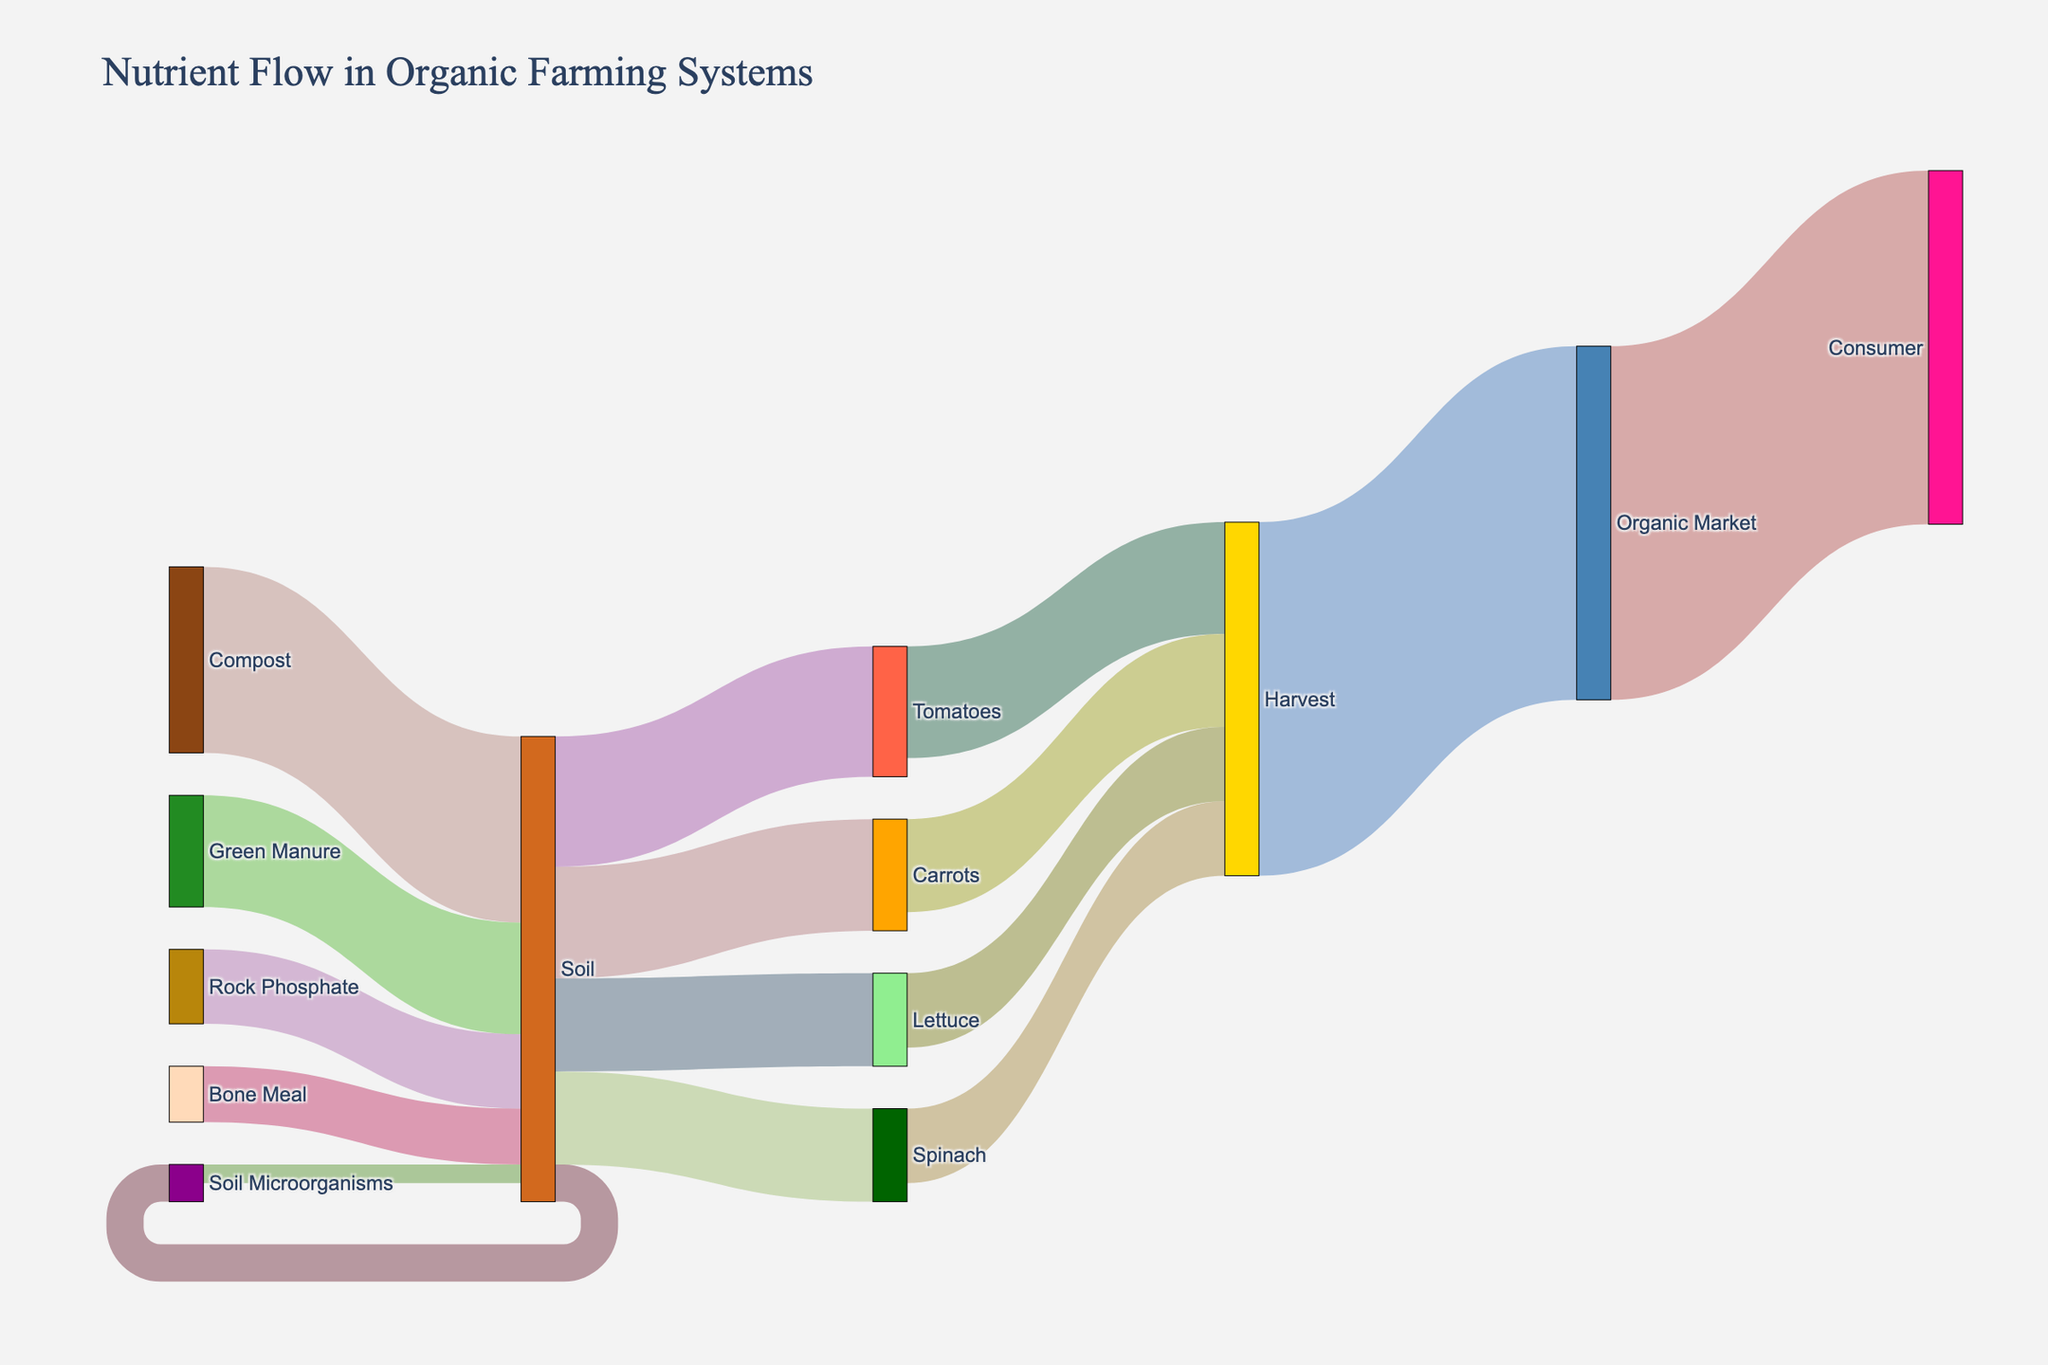what is the main source of nutrients to the soil? From the figure, the main source connecting to the "Soil" node is "Compost" with the highest value flow of 50.
Answer: Compost Which crop receives the most nutrients from the soil? The crop receiving the most nutrients from the "Soil" node, indicated by the highest value flow, is "Tomatoes" with a value of 35.
Answer: Tomatoes What is the total value of nutrients flowing into the soil? Adding up all the values pointing to "Soil" (Compost: 50, Green Manure: 30, Rock Phosphate: 20, Bone Meal: 15) yields 50 + 30 + 20 + 15 = 115.
Answer: 115 How many routes lead from "Soil" to "Harvest"? The "Soil" node connects to four crops (Lettuce, Tomatoes, Carrots, Spinach), each eventually leading to "Harvest", so there are four routes.
Answer: Four If the nutrient value for "Soil Microorganisms" flowing back to "Soil" is subtracted, what remains in "Soil"? "Soil Microorganisms" provide 5 units back to "Soil" after taking 10 from "Soil". So, 115 - (10 - 5) = 110 + 5 = 115 units remain.
Answer: 115 Compare the flow of nutrients from "Soil" to "Tomatoes" and from "Soil" to "Lettuce". From the figure, "Soil" to "Tomatoes" has a value of 35, which is greater than "Soil" to "Lettuce" with a value of 25.
Answer: Tomatoes > Lettuce What percentage of the nutrients harvested goes to the "Organic Market"? The total harvested nutrient value is 20 + 30 + 25 + 20 = 95, which 95 goes to the "Organic Market". Percentage = (95/95) * 100 = 100%.
Answer: 100% Which nutrient source has the lowest contribution to the soil? The lowest value among nutrient sources to "Soil" is "Bone Meal" with a value of 15.
Answer: Bone Meal How does the nutrient value for "Soil Microorganisms" compare with the nutrient value from "Green Manure" to "Soil"? "Soil Microorganisms" receive 10 units from "Soil" and "Green Manure" sends 30 units to "Soil". 10 is less than 30.
Answer: Less than What proportion of nutrients taken up by "Carrots" is eventually harvested? "Soil" to "Carrots" is 30, and "Carrots" to "Harvest" is 25. The proportion is 25/30.
Answer: 25/30 